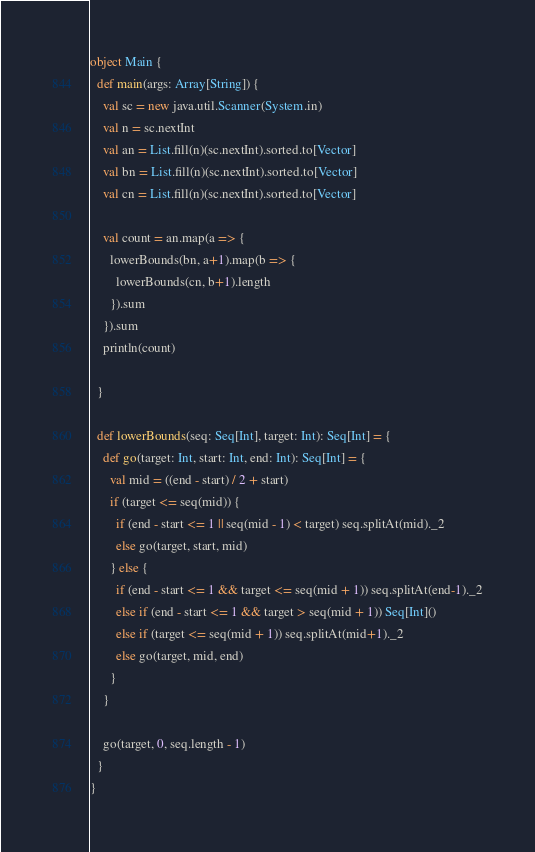<code> <loc_0><loc_0><loc_500><loc_500><_Scala_>object Main {
  def main(args: Array[String]) {
    val sc = new java.util.Scanner(System.in)
    val n = sc.nextInt
    val an = List.fill(n)(sc.nextInt).sorted.to[Vector]
    val bn = List.fill(n)(sc.nextInt).sorted.to[Vector]
    val cn = List.fill(n)(sc.nextInt).sorted.to[Vector]

    val count = an.map(a => {
      lowerBounds(bn, a+1).map(b => {
        lowerBounds(cn, b+1).length
      }).sum
    }).sum
    println(count)

  }

  def lowerBounds(seq: Seq[Int], target: Int): Seq[Int] = {
    def go(target: Int, start: Int, end: Int): Seq[Int] = {
      val mid = ((end - start) / 2 + start)
      if (target <= seq(mid)) {
        if (end - start <= 1 || seq(mid - 1) < target) seq.splitAt(mid)._2
        else go(target, start, mid)
      } else {
        if (end - start <= 1 && target <= seq(mid + 1)) seq.splitAt(end-1)._2
        else if (end - start <= 1 && target > seq(mid + 1)) Seq[Int]()
        else if (target <= seq(mid + 1)) seq.splitAt(mid+1)._2
        else go(target, mid, end)
      }
    }

    go(target, 0, seq.length - 1)
  }
}
</code> 